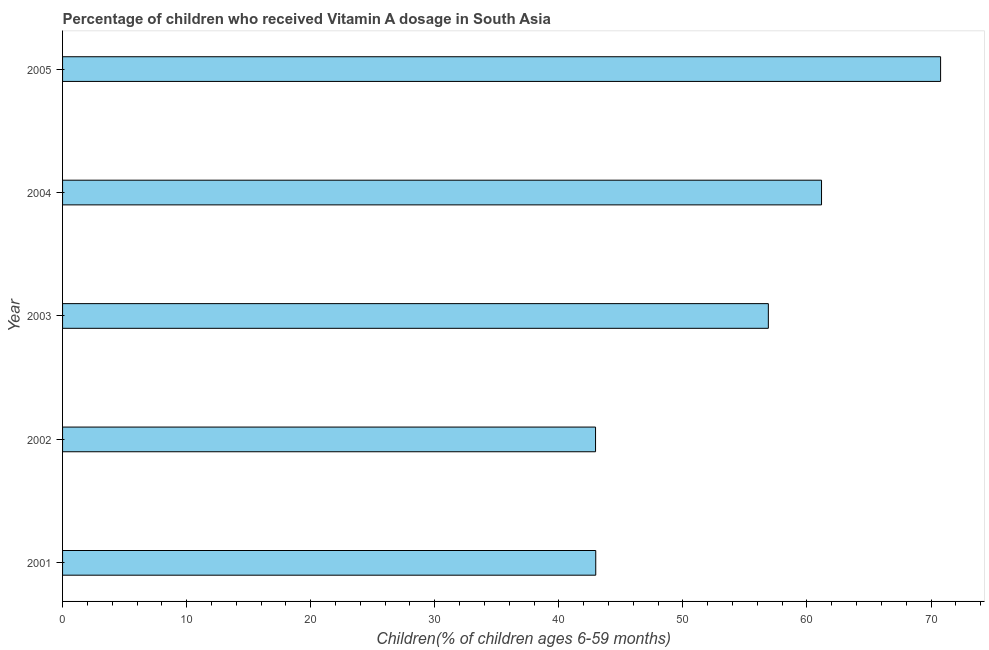Does the graph contain any zero values?
Make the answer very short. No. What is the title of the graph?
Provide a short and direct response. Percentage of children who received Vitamin A dosage in South Asia. What is the label or title of the X-axis?
Provide a short and direct response. Children(% of children ages 6-59 months). What is the vitamin a supplementation coverage rate in 2003?
Your response must be concise. 56.89. Across all years, what is the maximum vitamin a supplementation coverage rate?
Give a very brief answer. 70.77. Across all years, what is the minimum vitamin a supplementation coverage rate?
Your answer should be very brief. 42.96. In which year was the vitamin a supplementation coverage rate minimum?
Make the answer very short. 2002. What is the sum of the vitamin a supplementation coverage rate?
Provide a succinct answer. 274.77. What is the difference between the vitamin a supplementation coverage rate in 2002 and 2005?
Your answer should be very brief. -27.81. What is the average vitamin a supplementation coverage rate per year?
Your answer should be compact. 54.95. What is the median vitamin a supplementation coverage rate?
Offer a terse response. 56.89. Do a majority of the years between 2003 and 2001 (inclusive) have vitamin a supplementation coverage rate greater than 58 %?
Offer a very short reply. Yes. What is the ratio of the vitamin a supplementation coverage rate in 2001 to that in 2005?
Your answer should be compact. 0.61. Is the vitamin a supplementation coverage rate in 2001 less than that in 2005?
Your answer should be very brief. Yes. Is the difference between the vitamin a supplementation coverage rate in 2002 and 2005 greater than the difference between any two years?
Keep it short and to the point. Yes. What is the difference between the highest and the second highest vitamin a supplementation coverage rate?
Give a very brief answer. 9.6. What is the difference between the highest and the lowest vitamin a supplementation coverage rate?
Your answer should be compact. 27.81. How many bars are there?
Provide a succinct answer. 5. What is the difference between two consecutive major ticks on the X-axis?
Your response must be concise. 10. Are the values on the major ticks of X-axis written in scientific E-notation?
Keep it short and to the point. No. What is the Children(% of children ages 6-59 months) in 2001?
Give a very brief answer. 42.98. What is the Children(% of children ages 6-59 months) of 2002?
Ensure brevity in your answer.  42.96. What is the Children(% of children ages 6-59 months) of 2003?
Give a very brief answer. 56.89. What is the Children(% of children ages 6-59 months) of 2004?
Your answer should be very brief. 61.18. What is the Children(% of children ages 6-59 months) of 2005?
Provide a short and direct response. 70.77. What is the difference between the Children(% of children ages 6-59 months) in 2001 and 2002?
Keep it short and to the point. 0.02. What is the difference between the Children(% of children ages 6-59 months) in 2001 and 2003?
Keep it short and to the point. -13.91. What is the difference between the Children(% of children ages 6-59 months) in 2001 and 2004?
Make the answer very short. -18.2. What is the difference between the Children(% of children ages 6-59 months) in 2001 and 2005?
Your response must be concise. -27.8. What is the difference between the Children(% of children ages 6-59 months) in 2002 and 2003?
Give a very brief answer. -13.93. What is the difference between the Children(% of children ages 6-59 months) in 2002 and 2004?
Offer a very short reply. -18.22. What is the difference between the Children(% of children ages 6-59 months) in 2002 and 2005?
Your response must be concise. -27.81. What is the difference between the Children(% of children ages 6-59 months) in 2003 and 2004?
Keep it short and to the point. -4.29. What is the difference between the Children(% of children ages 6-59 months) in 2003 and 2005?
Ensure brevity in your answer.  -13.88. What is the difference between the Children(% of children ages 6-59 months) in 2004 and 2005?
Your answer should be compact. -9.6. What is the ratio of the Children(% of children ages 6-59 months) in 2001 to that in 2002?
Ensure brevity in your answer.  1. What is the ratio of the Children(% of children ages 6-59 months) in 2001 to that in 2003?
Ensure brevity in your answer.  0.76. What is the ratio of the Children(% of children ages 6-59 months) in 2001 to that in 2004?
Make the answer very short. 0.7. What is the ratio of the Children(% of children ages 6-59 months) in 2001 to that in 2005?
Keep it short and to the point. 0.61. What is the ratio of the Children(% of children ages 6-59 months) in 2002 to that in 2003?
Your answer should be very brief. 0.76. What is the ratio of the Children(% of children ages 6-59 months) in 2002 to that in 2004?
Provide a short and direct response. 0.7. What is the ratio of the Children(% of children ages 6-59 months) in 2002 to that in 2005?
Your response must be concise. 0.61. What is the ratio of the Children(% of children ages 6-59 months) in 2003 to that in 2004?
Make the answer very short. 0.93. What is the ratio of the Children(% of children ages 6-59 months) in 2003 to that in 2005?
Give a very brief answer. 0.8. What is the ratio of the Children(% of children ages 6-59 months) in 2004 to that in 2005?
Your answer should be compact. 0.86. 